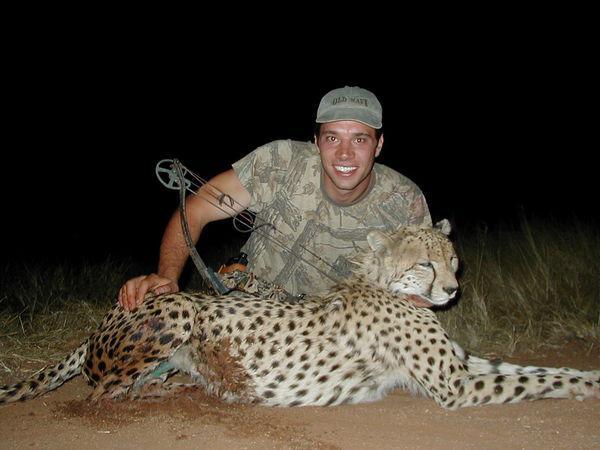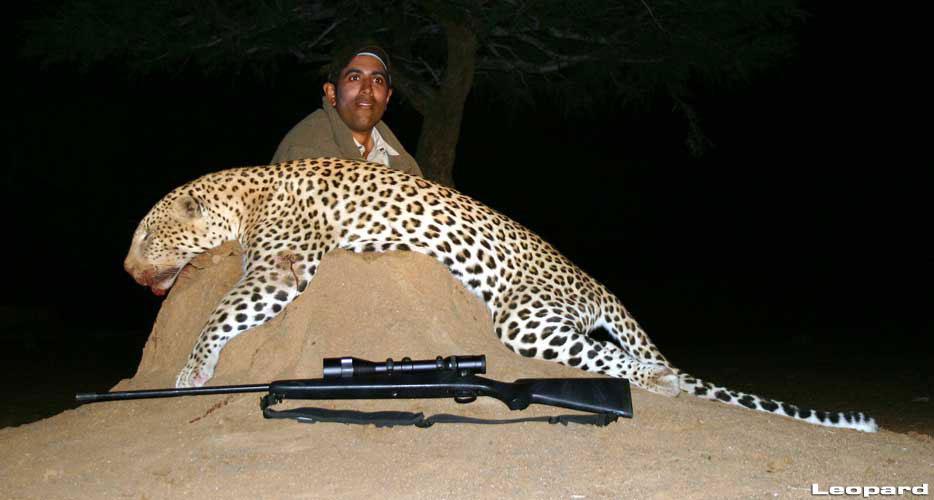The first image is the image on the left, the second image is the image on the right. Given the left and right images, does the statement "A man is holding the cat in one of the images upright." hold true? Answer yes or no. No. 